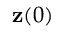Convert formula to latex. <formula><loc_0><loc_0><loc_500><loc_500>{ z } ( 0 )</formula> 